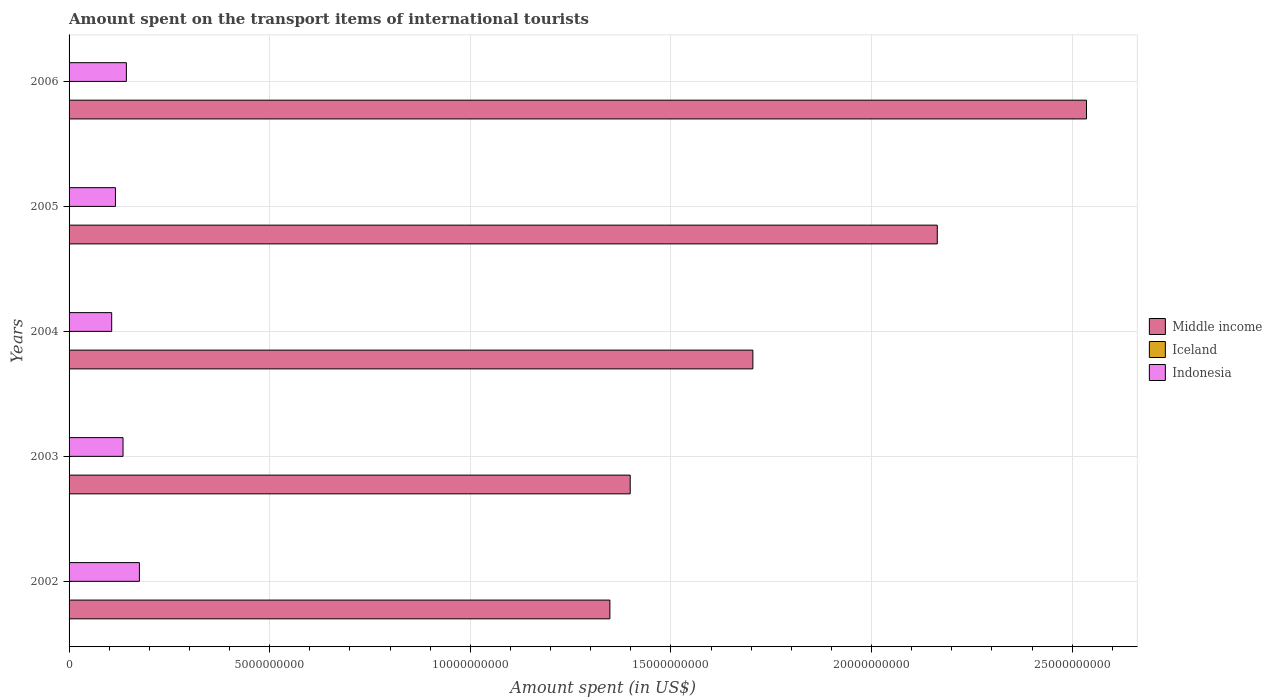How many different coloured bars are there?
Your response must be concise. 3. Are the number of bars per tick equal to the number of legend labels?
Make the answer very short. Yes. Are the number of bars on each tick of the Y-axis equal?
Keep it short and to the point. Yes. In how many cases, is the number of bars for a given year not equal to the number of legend labels?
Provide a short and direct response. 0. What is the amount spent on the transport items of international tourists in Iceland in 2003?
Keep it short and to the point. 1.00e+06. Across all years, what is the maximum amount spent on the transport items of international tourists in Iceland?
Your answer should be compact. 1.10e+07. Across all years, what is the minimum amount spent on the transport items of international tourists in Middle income?
Give a very brief answer. 1.35e+1. What is the total amount spent on the transport items of international tourists in Iceland in the graph?
Provide a succinct answer. 2.40e+07. What is the difference between the amount spent on the transport items of international tourists in Middle income in 2002 and that in 2005?
Provide a succinct answer. -8.16e+09. What is the difference between the amount spent on the transport items of international tourists in Indonesia in 2004 and the amount spent on the transport items of international tourists in Iceland in 2003?
Your answer should be very brief. 1.06e+09. What is the average amount spent on the transport items of international tourists in Middle income per year?
Your answer should be very brief. 1.83e+1. In the year 2004, what is the difference between the amount spent on the transport items of international tourists in Indonesia and amount spent on the transport items of international tourists in Middle income?
Make the answer very short. -1.60e+1. What is the ratio of the amount spent on the transport items of international tourists in Iceland in 2003 to that in 2005?
Your response must be concise. 0.09. Is the amount spent on the transport items of international tourists in Indonesia in 2004 less than that in 2005?
Make the answer very short. Yes. Is the difference between the amount spent on the transport items of international tourists in Indonesia in 2004 and 2006 greater than the difference between the amount spent on the transport items of international tourists in Middle income in 2004 and 2006?
Provide a succinct answer. Yes. What is the difference between the highest and the second highest amount spent on the transport items of international tourists in Indonesia?
Your response must be concise. 3.25e+08. What is the difference between the highest and the lowest amount spent on the transport items of international tourists in Indonesia?
Make the answer very short. 6.91e+08. Is the sum of the amount spent on the transport items of international tourists in Indonesia in 2002 and 2004 greater than the maximum amount spent on the transport items of international tourists in Middle income across all years?
Your response must be concise. No. What does the 2nd bar from the bottom in 2006 represents?
Your response must be concise. Iceland. Is it the case that in every year, the sum of the amount spent on the transport items of international tourists in Iceland and amount spent on the transport items of international tourists in Indonesia is greater than the amount spent on the transport items of international tourists in Middle income?
Your answer should be compact. No. How many bars are there?
Make the answer very short. 15. Are all the bars in the graph horizontal?
Your answer should be compact. Yes. How many years are there in the graph?
Keep it short and to the point. 5. Are the values on the major ticks of X-axis written in scientific E-notation?
Ensure brevity in your answer.  No. Where does the legend appear in the graph?
Your response must be concise. Center right. How are the legend labels stacked?
Your answer should be compact. Vertical. What is the title of the graph?
Ensure brevity in your answer.  Amount spent on the transport items of international tourists. What is the label or title of the X-axis?
Provide a short and direct response. Amount spent (in US$). What is the Amount spent (in US$) in Middle income in 2002?
Offer a terse response. 1.35e+1. What is the Amount spent (in US$) in Indonesia in 2002?
Make the answer very short. 1.75e+09. What is the Amount spent (in US$) of Middle income in 2003?
Provide a short and direct response. 1.40e+1. What is the Amount spent (in US$) of Iceland in 2003?
Make the answer very short. 1.00e+06. What is the Amount spent (in US$) of Indonesia in 2003?
Provide a short and direct response. 1.34e+09. What is the Amount spent (in US$) of Middle income in 2004?
Provide a succinct answer. 1.70e+1. What is the Amount spent (in US$) of Indonesia in 2004?
Provide a succinct answer. 1.06e+09. What is the Amount spent (in US$) of Middle income in 2005?
Ensure brevity in your answer.  2.16e+1. What is the Amount spent (in US$) of Iceland in 2005?
Provide a succinct answer. 1.10e+07. What is the Amount spent (in US$) in Indonesia in 2005?
Offer a very short reply. 1.16e+09. What is the Amount spent (in US$) in Middle income in 2006?
Make the answer very short. 2.54e+1. What is the Amount spent (in US$) in Iceland in 2006?
Provide a succinct answer. 8.00e+06. What is the Amount spent (in US$) of Indonesia in 2006?
Your answer should be compact. 1.43e+09. Across all years, what is the maximum Amount spent (in US$) in Middle income?
Provide a short and direct response. 2.54e+1. Across all years, what is the maximum Amount spent (in US$) of Iceland?
Your answer should be very brief. 1.10e+07. Across all years, what is the maximum Amount spent (in US$) of Indonesia?
Your response must be concise. 1.75e+09. Across all years, what is the minimum Amount spent (in US$) in Middle income?
Your response must be concise. 1.35e+1. Across all years, what is the minimum Amount spent (in US$) of Indonesia?
Offer a terse response. 1.06e+09. What is the total Amount spent (in US$) of Middle income in the graph?
Ensure brevity in your answer.  9.15e+1. What is the total Amount spent (in US$) in Iceland in the graph?
Keep it short and to the point. 2.40e+07. What is the total Amount spent (in US$) of Indonesia in the graph?
Provide a succinct answer. 6.74e+09. What is the difference between the Amount spent (in US$) of Middle income in 2002 and that in 2003?
Your answer should be very brief. -5.06e+08. What is the difference between the Amount spent (in US$) of Indonesia in 2002 and that in 2003?
Your response must be concise. 4.08e+08. What is the difference between the Amount spent (in US$) in Middle income in 2002 and that in 2004?
Provide a short and direct response. -3.56e+09. What is the difference between the Amount spent (in US$) in Iceland in 2002 and that in 2004?
Provide a succinct answer. 0. What is the difference between the Amount spent (in US$) of Indonesia in 2002 and that in 2004?
Offer a very short reply. 6.91e+08. What is the difference between the Amount spent (in US$) of Middle income in 2002 and that in 2005?
Provide a short and direct response. -8.16e+09. What is the difference between the Amount spent (in US$) of Iceland in 2002 and that in 2005?
Your answer should be very brief. -9.00e+06. What is the difference between the Amount spent (in US$) in Indonesia in 2002 and that in 2005?
Keep it short and to the point. 5.97e+08. What is the difference between the Amount spent (in US$) in Middle income in 2002 and that in 2006?
Provide a succinct answer. -1.19e+1. What is the difference between the Amount spent (in US$) in Iceland in 2002 and that in 2006?
Your answer should be compact. -6.00e+06. What is the difference between the Amount spent (in US$) in Indonesia in 2002 and that in 2006?
Offer a terse response. 3.25e+08. What is the difference between the Amount spent (in US$) of Middle income in 2003 and that in 2004?
Your response must be concise. -3.06e+09. What is the difference between the Amount spent (in US$) in Iceland in 2003 and that in 2004?
Your answer should be compact. -1.00e+06. What is the difference between the Amount spent (in US$) of Indonesia in 2003 and that in 2004?
Make the answer very short. 2.83e+08. What is the difference between the Amount spent (in US$) of Middle income in 2003 and that in 2005?
Make the answer very short. -7.65e+09. What is the difference between the Amount spent (in US$) in Iceland in 2003 and that in 2005?
Your answer should be compact. -1.00e+07. What is the difference between the Amount spent (in US$) in Indonesia in 2003 and that in 2005?
Give a very brief answer. 1.89e+08. What is the difference between the Amount spent (in US$) of Middle income in 2003 and that in 2006?
Provide a short and direct response. -1.14e+1. What is the difference between the Amount spent (in US$) of Iceland in 2003 and that in 2006?
Make the answer very short. -7.00e+06. What is the difference between the Amount spent (in US$) of Indonesia in 2003 and that in 2006?
Offer a very short reply. -8.30e+07. What is the difference between the Amount spent (in US$) in Middle income in 2004 and that in 2005?
Give a very brief answer. -4.60e+09. What is the difference between the Amount spent (in US$) in Iceland in 2004 and that in 2005?
Provide a succinct answer. -9.00e+06. What is the difference between the Amount spent (in US$) in Indonesia in 2004 and that in 2005?
Provide a succinct answer. -9.40e+07. What is the difference between the Amount spent (in US$) of Middle income in 2004 and that in 2006?
Make the answer very short. -8.31e+09. What is the difference between the Amount spent (in US$) in Iceland in 2004 and that in 2006?
Provide a succinct answer. -6.00e+06. What is the difference between the Amount spent (in US$) of Indonesia in 2004 and that in 2006?
Make the answer very short. -3.66e+08. What is the difference between the Amount spent (in US$) of Middle income in 2005 and that in 2006?
Provide a short and direct response. -3.72e+09. What is the difference between the Amount spent (in US$) in Indonesia in 2005 and that in 2006?
Offer a very short reply. -2.72e+08. What is the difference between the Amount spent (in US$) of Middle income in 2002 and the Amount spent (in US$) of Iceland in 2003?
Keep it short and to the point. 1.35e+1. What is the difference between the Amount spent (in US$) of Middle income in 2002 and the Amount spent (in US$) of Indonesia in 2003?
Provide a short and direct response. 1.21e+1. What is the difference between the Amount spent (in US$) in Iceland in 2002 and the Amount spent (in US$) in Indonesia in 2003?
Offer a terse response. -1.34e+09. What is the difference between the Amount spent (in US$) in Middle income in 2002 and the Amount spent (in US$) in Iceland in 2004?
Your response must be concise. 1.35e+1. What is the difference between the Amount spent (in US$) of Middle income in 2002 and the Amount spent (in US$) of Indonesia in 2004?
Your answer should be very brief. 1.24e+1. What is the difference between the Amount spent (in US$) in Iceland in 2002 and the Amount spent (in US$) in Indonesia in 2004?
Provide a short and direct response. -1.06e+09. What is the difference between the Amount spent (in US$) of Middle income in 2002 and the Amount spent (in US$) of Iceland in 2005?
Your response must be concise. 1.35e+1. What is the difference between the Amount spent (in US$) of Middle income in 2002 and the Amount spent (in US$) of Indonesia in 2005?
Your answer should be compact. 1.23e+1. What is the difference between the Amount spent (in US$) in Iceland in 2002 and the Amount spent (in US$) in Indonesia in 2005?
Offer a terse response. -1.15e+09. What is the difference between the Amount spent (in US$) of Middle income in 2002 and the Amount spent (in US$) of Iceland in 2006?
Ensure brevity in your answer.  1.35e+1. What is the difference between the Amount spent (in US$) in Middle income in 2002 and the Amount spent (in US$) in Indonesia in 2006?
Ensure brevity in your answer.  1.21e+1. What is the difference between the Amount spent (in US$) in Iceland in 2002 and the Amount spent (in US$) in Indonesia in 2006?
Your response must be concise. -1.43e+09. What is the difference between the Amount spent (in US$) of Middle income in 2003 and the Amount spent (in US$) of Iceland in 2004?
Your response must be concise. 1.40e+1. What is the difference between the Amount spent (in US$) in Middle income in 2003 and the Amount spent (in US$) in Indonesia in 2004?
Your answer should be compact. 1.29e+1. What is the difference between the Amount spent (in US$) of Iceland in 2003 and the Amount spent (in US$) of Indonesia in 2004?
Give a very brief answer. -1.06e+09. What is the difference between the Amount spent (in US$) of Middle income in 2003 and the Amount spent (in US$) of Iceland in 2005?
Your answer should be very brief. 1.40e+1. What is the difference between the Amount spent (in US$) of Middle income in 2003 and the Amount spent (in US$) of Indonesia in 2005?
Make the answer very short. 1.28e+1. What is the difference between the Amount spent (in US$) in Iceland in 2003 and the Amount spent (in US$) in Indonesia in 2005?
Your answer should be very brief. -1.16e+09. What is the difference between the Amount spent (in US$) in Middle income in 2003 and the Amount spent (in US$) in Iceland in 2006?
Your answer should be compact. 1.40e+1. What is the difference between the Amount spent (in US$) of Middle income in 2003 and the Amount spent (in US$) of Indonesia in 2006?
Ensure brevity in your answer.  1.26e+1. What is the difference between the Amount spent (in US$) of Iceland in 2003 and the Amount spent (in US$) of Indonesia in 2006?
Your answer should be very brief. -1.43e+09. What is the difference between the Amount spent (in US$) in Middle income in 2004 and the Amount spent (in US$) in Iceland in 2005?
Offer a very short reply. 1.70e+1. What is the difference between the Amount spent (in US$) of Middle income in 2004 and the Amount spent (in US$) of Indonesia in 2005?
Provide a short and direct response. 1.59e+1. What is the difference between the Amount spent (in US$) of Iceland in 2004 and the Amount spent (in US$) of Indonesia in 2005?
Ensure brevity in your answer.  -1.15e+09. What is the difference between the Amount spent (in US$) in Middle income in 2004 and the Amount spent (in US$) in Iceland in 2006?
Offer a terse response. 1.70e+1. What is the difference between the Amount spent (in US$) of Middle income in 2004 and the Amount spent (in US$) of Indonesia in 2006?
Your answer should be compact. 1.56e+1. What is the difference between the Amount spent (in US$) in Iceland in 2004 and the Amount spent (in US$) in Indonesia in 2006?
Your answer should be very brief. -1.43e+09. What is the difference between the Amount spent (in US$) in Middle income in 2005 and the Amount spent (in US$) in Iceland in 2006?
Offer a terse response. 2.16e+1. What is the difference between the Amount spent (in US$) of Middle income in 2005 and the Amount spent (in US$) of Indonesia in 2006?
Provide a short and direct response. 2.02e+1. What is the difference between the Amount spent (in US$) in Iceland in 2005 and the Amount spent (in US$) in Indonesia in 2006?
Offer a very short reply. -1.42e+09. What is the average Amount spent (in US$) of Middle income per year?
Your response must be concise. 1.83e+1. What is the average Amount spent (in US$) of Iceland per year?
Your answer should be very brief. 4.80e+06. What is the average Amount spent (in US$) of Indonesia per year?
Give a very brief answer. 1.35e+09. In the year 2002, what is the difference between the Amount spent (in US$) of Middle income and Amount spent (in US$) of Iceland?
Your answer should be compact. 1.35e+1. In the year 2002, what is the difference between the Amount spent (in US$) in Middle income and Amount spent (in US$) in Indonesia?
Offer a terse response. 1.17e+1. In the year 2002, what is the difference between the Amount spent (in US$) of Iceland and Amount spent (in US$) of Indonesia?
Your answer should be very brief. -1.75e+09. In the year 2003, what is the difference between the Amount spent (in US$) in Middle income and Amount spent (in US$) in Iceland?
Provide a short and direct response. 1.40e+1. In the year 2003, what is the difference between the Amount spent (in US$) of Middle income and Amount spent (in US$) of Indonesia?
Your answer should be very brief. 1.26e+1. In the year 2003, what is the difference between the Amount spent (in US$) of Iceland and Amount spent (in US$) of Indonesia?
Make the answer very short. -1.34e+09. In the year 2004, what is the difference between the Amount spent (in US$) in Middle income and Amount spent (in US$) in Iceland?
Provide a succinct answer. 1.70e+1. In the year 2004, what is the difference between the Amount spent (in US$) in Middle income and Amount spent (in US$) in Indonesia?
Provide a succinct answer. 1.60e+1. In the year 2004, what is the difference between the Amount spent (in US$) of Iceland and Amount spent (in US$) of Indonesia?
Give a very brief answer. -1.06e+09. In the year 2005, what is the difference between the Amount spent (in US$) of Middle income and Amount spent (in US$) of Iceland?
Provide a short and direct response. 2.16e+1. In the year 2005, what is the difference between the Amount spent (in US$) in Middle income and Amount spent (in US$) in Indonesia?
Your response must be concise. 2.05e+1. In the year 2005, what is the difference between the Amount spent (in US$) in Iceland and Amount spent (in US$) in Indonesia?
Ensure brevity in your answer.  -1.14e+09. In the year 2006, what is the difference between the Amount spent (in US$) in Middle income and Amount spent (in US$) in Iceland?
Keep it short and to the point. 2.53e+1. In the year 2006, what is the difference between the Amount spent (in US$) of Middle income and Amount spent (in US$) of Indonesia?
Provide a short and direct response. 2.39e+1. In the year 2006, what is the difference between the Amount spent (in US$) in Iceland and Amount spent (in US$) in Indonesia?
Keep it short and to the point. -1.42e+09. What is the ratio of the Amount spent (in US$) in Middle income in 2002 to that in 2003?
Give a very brief answer. 0.96. What is the ratio of the Amount spent (in US$) in Iceland in 2002 to that in 2003?
Give a very brief answer. 2. What is the ratio of the Amount spent (in US$) in Indonesia in 2002 to that in 2003?
Give a very brief answer. 1.3. What is the ratio of the Amount spent (in US$) in Middle income in 2002 to that in 2004?
Your answer should be very brief. 0.79. What is the ratio of the Amount spent (in US$) of Indonesia in 2002 to that in 2004?
Your answer should be compact. 1.65. What is the ratio of the Amount spent (in US$) in Middle income in 2002 to that in 2005?
Keep it short and to the point. 0.62. What is the ratio of the Amount spent (in US$) in Iceland in 2002 to that in 2005?
Offer a very short reply. 0.18. What is the ratio of the Amount spent (in US$) of Indonesia in 2002 to that in 2005?
Offer a terse response. 1.52. What is the ratio of the Amount spent (in US$) in Middle income in 2002 to that in 2006?
Provide a succinct answer. 0.53. What is the ratio of the Amount spent (in US$) in Iceland in 2002 to that in 2006?
Your answer should be very brief. 0.25. What is the ratio of the Amount spent (in US$) of Indonesia in 2002 to that in 2006?
Make the answer very short. 1.23. What is the ratio of the Amount spent (in US$) in Middle income in 2003 to that in 2004?
Offer a terse response. 0.82. What is the ratio of the Amount spent (in US$) in Iceland in 2003 to that in 2004?
Offer a terse response. 0.5. What is the ratio of the Amount spent (in US$) of Indonesia in 2003 to that in 2004?
Your answer should be very brief. 1.27. What is the ratio of the Amount spent (in US$) of Middle income in 2003 to that in 2005?
Your answer should be very brief. 0.65. What is the ratio of the Amount spent (in US$) of Iceland in 2003 to that in 2005?
Keep it short and to the point. 0.09. What is the ratio of the Amount spent (in US$) of Indonesia in 2003 to that in 2005?
Provide a short and direct response. 1.16. What is the ratio of the Amount spent (in US$) of Middle income in 2003 to that in 2006?
Your answer should be compact. 0.55. What is the ratio of the Amount spent (in US$) in Iceland in 2003 to that in 2006?
Your answer should be very brief. 0.12. What is the ratio of the Amount spent (in US$) in Indonesia in 2003 to that in 2006?
Your answer should be compact. 0.94. What is the ratio of the Amount spent (in US$) of Middle income in 2004 to that in 2005?
Your answer should be very brief. 0.79. What is the ratio of the Amount spent (in US$) in Iceland in 2004 to that in 2005?
Your answer should be compact. 0.18. What is the ratio of the Amount spent (in US$) of Indonesia in 2004 to that in 2005?
Make the answer very short. 0.92. What is the ratio of the Amount spent (in US$) in Middle income in 2004 to that in 2006?
Offer a very short reply. 0.67. What is the ratio of the Amount spent (in US$) in Iceland in 2004 to that in 2006?
Ensure brevity in your answer.  0.25. What is the ratio of the Amount spent (in US$) in Indonesia in 2004 to that in 2006?
Keep it short and to the point. 0.74. What is the ratio of the Amount spent (in US$) of Middle income in 2005 to that in 2006?
Your response must be concise. 0.85. What is the ratio of the Amount spent (in US$) in Iceland in 2005 to that in 2006?
Give a very brief answer. 1.38. What is the ratio of the Amount spent (in US$) in Indonesia in 2005 to that in 2006?
Your answer should be compact. 0.81. What is the difference between the highest and the second highest Amount spent (in US$) of Middle income?
Provide a short and direct response. 3.72e+09. What is the difference between the highest and the second highest Amount spent (in US$) in Indonesia?
Make the answer very short. 3.25e+08. What is the difference between the highest and the lowest Amount spent (in US$) in Middle income?
Ensure brevity in your answer.  1.19e+1. What is the difference between the highest and the lowest Amount spent (in US$) of Iceland?
Provide a short and direct response. 1.00e+07. What is the difference between the highest and the lowest Amount spent (in US$) of Indonesia?
Ensure brevity in your answer.  6.91e+08. 